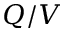Convert formula to latex. <formula><loc_0><loc_0><loc_500><loc_500>Q / V</formula> 